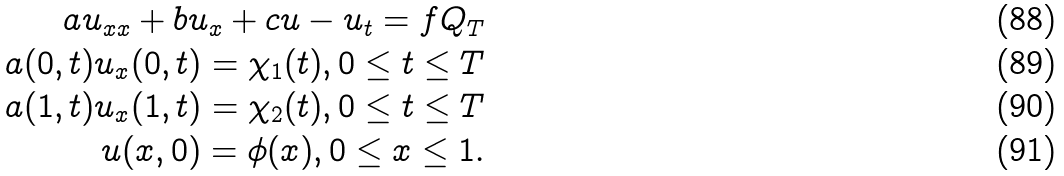<formula> <loc_0><loc_0><loc_500><loc_500>a u _ { x x } + b u _ { x } + c u - u _ { t } = f Q _ { T } \\ a ( 0 , t ) u _ { x } ( 0 , t ) = \chi _ { 1 } ( t ) , 0 \leq t \leq T \\ a ( 1 , t ) u _ { x } ( 1 , t ) = \chi _ { 2 } ( t ) , 0 \leq t \leq T \\ u ( x , 0 ) = \phi ( x ) , 0 \leq x \leq 1 .</formula> 